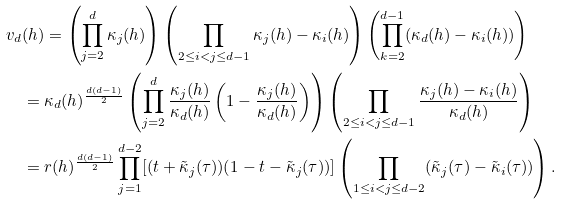Convert formula to latex. <formula><loc_0><loc_0><loc_500><loc_500>v _ { d } & ( h ) = \left ( \prod _ { j = 2 } ^ { d } \kappa _ { j } ( h ) \right ) \left ( \prod _ { 2 \leq i < j \leq d - 1 } \kappa _ { j } ( h ) - \kappa _ { i } ( h ) \right ) \left ( \prod _ { k = 2 } ^ { d - 1 } ( \kappa _ { d } ( h ) - \kappa _ { i } ( h ) ) \right ) \\ & = \kappa _ { d } ( h ) ^ { \frac { d ( d - 1 ) } { 2 } } \left ( \prod _ { j = 2 } ^ { d } \frac { \kappa _ { j } ( h ) } { \kappa _ { d } ( h ) } \left ( 1 - \frac { \kappa _ { j } ( h ) } { \kappa _ { d } ( h ) } \right ) \right ) \left ( \prod _ { 2 \leq i < j \leq d - 1 } \frac { \kappa _ { j } ( h ) - \kappa _ { i } ( h ) } { \kappa _ { d } ( h ) } \right ) \\ & = r ( h ) ^ { \frac { d ( d - 1 ) } { 2 } } \prod _ { j = 1 } ^ { d - 2 } [ ( t + \tilde { \kappa } _ { j } ( \tau ) ) ( 1 - t - \tilde { \kappa } _ { j } ( \tau ) ) ] \left ( \prod _ { 1 \leq i < j \leq d - 2 } ( \tilde { \kappa } _ { j } ( \tau ) - \tilde { \kappa } _ { i } ( \tau ) ) \right ) .</formula> 